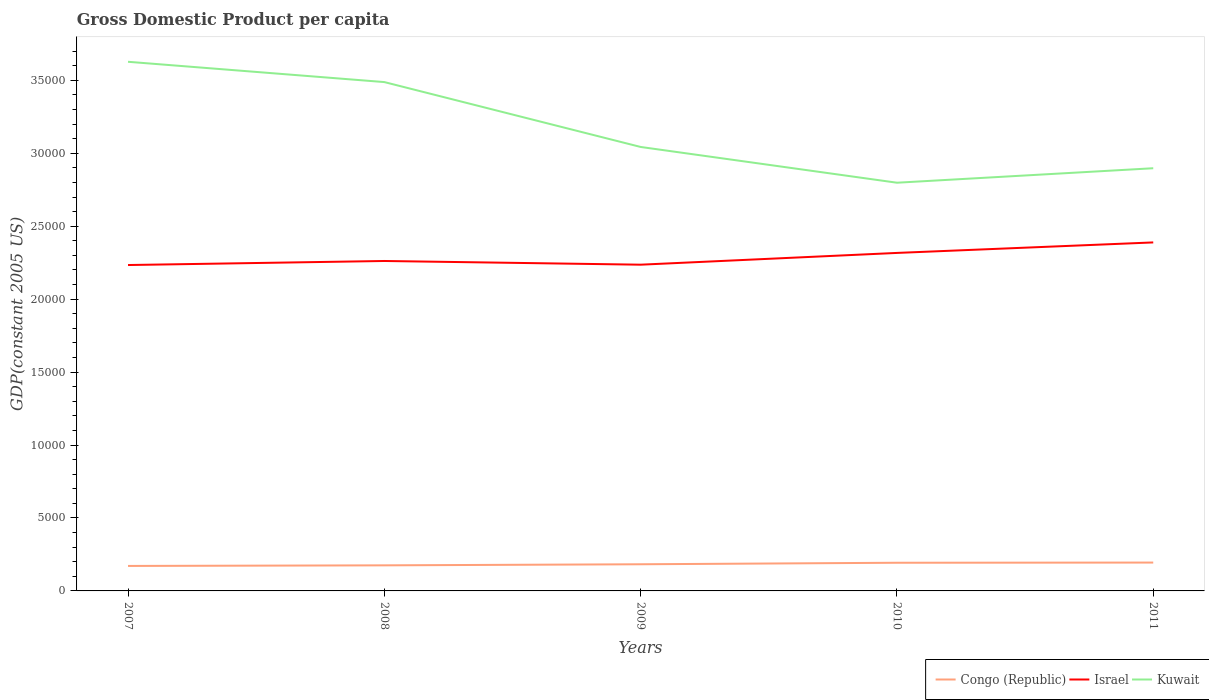Does the line corresponding to Congo (Republic) intersect with the line corresponding to Israel?
Offer a terse response. No. Across all years, what is the maximum GDP per capita in Kuwait?
Offer a terse response. 2.80e+04. In which year was the GDP per capita in Israel maximum?
Make the answer very short. 2007. What is the total GDP per capita in Congo (Republic) in the graph?
Make the answer very short. -231.26. What is the difference between the highest and the second highest GDP per capita in Israel?
Offer a very short reply. 1550.52. How many lines are there?
Offer a very short reply. 3. How many years are there in the graph?
Keep it short and to the point. 5. What is the difference between two consecutive major ticks on the Y-axis?
Make the answer very short. 5000. Does the graph contain grids?
Keep it short and to the point. No. Where does the legend appear in the graph?
Ensure brevity in your answer.  Bottom right. What is the title of the graph?
Offer a terse response. Gross Domestic Product per capita. Does "Zambia" appear as one of the legend labels in the graph?
Offer a terse response. No. What is the label or title of the X-axis?
Provide a succinct answer. Years. What is the label or title of the Y-axis?
Your answer should be very brief. GDP(constant 2005 US). What is the GDP(constant 2005 US) in Congo (Republic) in 2007?
Your answer should be very brief. 1712.82. What is the GDP(constant 2005 US) of Israel in 2007?
Keep it short and to the point. 2.23e+04. What is the GDP(constant 2005 US) of Kuwait in 2007?
Keep it short and to the point. 3.63e+04. What is the GDP(constant 2005 US) in Congo (Republic) in 2008?
Offer a terse response. 1753.02. What is the GDP(constant 2005 US) of Israel in 2008?
Your response must be concise. 2.26e+04. What is the GDP(constant 2005 US) of Kuwait in 2008?
Offer a very short reply. 3.49e+04. What is the GDP(constant 2005 US) of Congo (Republic) in 2009?
Offer a terse response. 1827.67. What is the GDP(constant 2005 US) in Israel in 2009?
Provide a succinct answer. 2.24e+04. What is the GDP(constant 2005 US) of Kuwait in 2009?
Offer a terse response. 3.04e+04. What is the GDP(constant 2005 US) in Congo (Republic) in 2010?
Your answer should be very brief. 1931.26. What is the GDP(constant 2005 US) in Israel in 2010?
Provide a succinct answer. 2.32e+04. What is the GDP(constant 2005 US) in Kuwait in 2010?
Offer a terse response. 2.80e+04. What is the GDP(constant 2005 US) of Congo (Republic) in 2011?
Your answer should be compact. 1944.08. What is the GDP(constant 2005 US) of Israel in 2011?
Provide a short and direct response. 2.39e+04. What is the GDP(constant 2005 US) of Kuwait in 2011?
Keep it short and to the point. 2.90e+04. Across all years, what is the maximum GDP(constant 2005 US) of Congo (Republic)?
Your answer should be very brief. 1944.08. Across all years, what is the maximum GDP(constant 2005 US) in Israel?
Provide a short and direct response. 2.39e+04. Across all years, what is the maximum GDP(constant 2005 US) of Kuwait?
Give a very brief answer. 3.63e+04. Across all years, what is the minimum GDP(constant 2005 US) in Congo (Republic)?
Provide a short and direct response. 1712.82. Across all years, what is the minimum GDP(constant 2005 US) in Israel?
Provide a succinct answer. 2.23e+04. Across all years, what is the minimum GDP(constant 2005 US) of Kuwait?
Offer a very short reply. 2.80e+04. What is the total GDP(constant 2005 US) of Congo (Republic) in the graph?
Give a very brief answer. 9168.85. What is the total GDP(constant 2005 US) of Israel in the graph?
Give a very brief answer. 1.14e+05. What is the total GDP(constant 2005 US) in Kuwait in the graph?
Offer a terse response. 1.59e+05. What is the difference between the GDP(constant 2005 US) in Congo (Republic) in 2007 and that in 2008?
Give a very brief answer. -40.19. What is the difference between the GDP(constant 2005 US) in Israel in 2007 and that in 2008?
Your answer should be compact. -278.04. What is the difference between the GDP(constant 2005 US) of Kuwait in 2007 and that in 2008?
Offer a terse response. 1391. What is the difference between the GDP(constant 2005 US) of Congo (Republic) in 2007 and that in 2009?
Give a very brief answer. -114.85. What is the difference between the GDP(constant 2005 US) of Israel in 2007 and that in 2009?
Offer a very short reply. -24.01. What is the difference between the GDP(constant 2005 US) in Kuwait in 2007 and that in 2009?
Ensure brevity in your answer.  5838.59. What is the difference between the GDP(constant 2005 US) in Congo (Republic) in 2007 and that in 2010?
Your response must be concise. -218.44. What is the difference between the GDP(constant 2005 US) of Israel in 2007 and that in 2010?
Your answer should be very brief. -830.64. What is the difference between the GDP(constant 2005 US) in Kuwait in 2007 and that in 2010?
Offer a terse response. 8289.89. What is the difference between the GDP(constant 2005 US) in Congo (Republic) in 2007 and that in 2011?
Offer a very short reply. -231.26. What is the difference between the GDP(constant 2005 US) in Israel in 2007 and that in 2011?
Your answer should be compact. -1550.52. What is the difference between the GDP(constant 2005 US) of Kuwait in 2007 and that in 2011?
Offer a very short reply. 7297.57. What is the difference between the GDP(constant 2005 US) in Congo (Republic) in 2008 and that in 2009?
Offer a very short reply. -74.65. What is the difference between the GDP(constant 2005 US) in Israel in 2008 and that in 2009?
Offer a very short reply. 254.03. What is the difference between the GDP(constant 2005 US) of Kuwait in 2008 and that in 2009?
Your response must be concise. 4447.59. What is the difference between the GDP(constant 2005 US) in Congo (Republic) in 2008 and that in 2010?
Your answer should be compact. -178.25. What is the difference between the GDP(constant 2005 US) of Israel in 2008 and that in 2010?
Ensure brevity in your answer.  -552.6. What is the difference between the GDP(constant 2005 US) of Kuwait in 2008 and that in 2010?
Offer a very short reply. 6898.89. What is the difference between the GDP(constant 2005 US) of Congo (Republic) in 2008 and that in 2011?
Make the answer very short. -191.07. What is the difference between the GDP(constant 2005 US) in Israel in 2008 and that in 2011?
Your answer should be very brief. -1272.48. What is the difference between the GDP(constant 2005 US) in Kuwait in 2008 and that in 2011?
Offer a terse response. 5906.57. What is the difference between the GDP(constant 2005 US) of Congo (Republic) in 2009 and that in 2010?
Ensure brevity in your answer.  -103.59. What is the difference between the GDP(constant 2005 US) of Israel in 2009 and that in 2010?
Give a very brief answer. -806.63. What is the difference between the GDP(constant 2005 US) of Kuwait in 2009 and that in 2010?
Ensure brevity in your answer.  2451.3. What is the difference between the GDP(constant 2005 US) in Congo (Republic) in 2009 and that in 2011?
Your answer should be compact. -116.41. What is the difference between the GDP(constant 2005 US) of Israel in 2009 and that in 2011?
Offer a terse response. -1526.51. What is the difference between the GDP(constant 2005 US) of Kuwait in 2009 and that in 2011?
Your answer should be compact. 1458.97. What is the difference between the GDP(constant 2005 US) in Congo (Republic) in 2010 and that in 2011?
Provide a short and direct response. -12.82. What is the difference between the GDP(constant 2005 US) of Israel in 2010 and that in 2011?
Keep it short and to the point. -719.88. What is the difference between the GDP(constant 2005 US) in Kuwait in 2010 and that in 2011?
Offer a terse response. -992.33. What is the difference between the GDP(constant 2005 US) in Congo (Republic) in 2007 and the GDP(constant 2005 US) in Israel in 2008?
Offer a terse response. -2.09e+04. What is the difference between the GDP(constant 2005 US) of Congo (Republic) in 2007 and the GDP(constant 2005 US) of Kuwait in 2008?
Offer a very short reply. -3.32e+04. What is the difference between the GDP(constant 2005 US) of Israel in 2007 and the GDP(constant 2005 US) of Kuwait in 2008?
Make the answer very short. -1.25e+04. What is the difference between the GDP(constant 2005 US) of Congo (Republic) in 2007 and the GDP(constant 2005 US) of Israel in 2009?
Your answer should be very brief. -2.07e+04. What is the difference between the GDP(constant 2005 US) in Congo (Republic) in 2007 and the GDP(constant 2005 US) in Kuwait in 2009?
Ensure brevity in your answer.  -2.87e+04. What is the difference between the GDP(constant 2005 US) of Israel in 2007 and the GDP(constant 2005 US) of Kuwait in 2009?
Your answer should be compact. -8094.24. What is the difference between the GDP(constant 2005 US) in Congo (Republic) in 2007 and the GDP(constant 2005 US) in Israel in 2010?
Offer a very short reply. -2.15e+04. What is the difference between the GDP(constant 2005 US) of Congo (Republic) in 2007 and the GDP(constant 2005 US) of Kuwait in 2010?
Offer a very short reply. -2.63e+04. What is the difference between the GDP(constant 2005 US) of Israel in 2007 and the GDP(constant 2005 US) of Kuwait in 2010?
Offer a very short reply. -5642.94. What is the difference between the GDP(constant 2005 US) of Congo (Republic) in 2007 and the GDP(constant 2005 US) of Israel in 2011?
Give a very brief answer. -2.22e+04. What is the difference between the GDP(constant 2005 US) of Congo (Republic) in 2007 and the GDP(constant 2005 US) of Kuwait in 2011?
Your answer should be compact. -2.73e+04. What is the difference between the GDP(constant 2005 US) of Israel in 2007 and the GDP(constant 2005 US) of Kuwait in 2011?
Your answer should be very brief. -6635.26. What is the difference between the GDP(constant 2005 US) in Congo (Republic) in 2008 and the GDP(constant 2005 US) in Israel in 2009?
Your answer should be compact. -2.06e+04. What is the difference between the GDP(constant 2005 US) in Congo (Republic) in 2008 and the GDP(constant 2005 US) in Kuwait in 2009?
Your answer should be compact. -2.87e+04. What is the difference between the GDP(constant 2005 US) of Israel in 2008 and the GDP(constant 2005 US) of Kuwait in 2009?
Your response must be concise. -7816.2. What is the difference between the GDP(constant 2005 US) in Congo (Republic) in 2008 and the GDP(constant 2005 US) in Israel in 2010?
Provide a short and direct response. -2.14e+04. What is the difference between the GDP(constant 2005 US) of Congo (Republic) in 2008 and the GDP(constant 2005 US) of Kuwait in 2010?
Provide a short and direct response. -2.62e+04. What is the difference between the GDP(constant 2005 US) in Israel in 2008 and the GDP(constant 2005 US) in Kuwait in 2010?
Ensure brevity in your answer.  -5364.89. What is the difference between the GDP(constant 2005 US) in Congo (Republic) in 2008 and the GDP(constant 2005 US) in Israel in 2011?
Offer a very short reply. -2.21e+04. What is the difference between the GDP(constant 2005 US) in Congo (Republic) in 2008 and the GDP(constant 2005 US) in Kuwait in 2011?
Your response must be concise. -2.72e+04. What is the difference between the GDP(constant 2005 US) of Israel in 2008 and the GDP(constant 2005 US) of Kuwait in 2011?
Ensure brevity in your answer.  -6357.22. What is the difference between the GDP(constant 2005 US) of Congo (Republic) in 2009 and the GDP(constant 2005 US) of Israel in 2010?
Your response must be concise. -2.13e+04. What is the difference between the GDP(constant 2005 US) in Congo (Republic) in 2009 and the GDP(constant 2005 US) in Kuwait in 2010?
Provide a short and direct response. -2.62e+04. What is the difference between the GDP(constant 2005 US) of Israel in 2009 and the GDP(constant 2005 US) of Kuwait in 2010?
Give a very brief answer. -5618.92. What is the difference between the GDP(constant 2005 US) in Congo (Republic) in 2009 and the GDP(constant 2005 US) in Israel in 2011?
Provide a short and direct response. -2.21e+04. What is the difference between the GDP(constant 2005 US) of Congo (Republic) in 2009 and the GDP(constant 2005 US) of Kuwait in 2011?
Make the answer very short. -2.71e+04. What is the difference between the GDP(constant 2005 US) in Israel in 2009 and the GDP(constant 2005 US) in Kuwait in 2011?
Offer a very short reply. -6611.25. What is the difference between the GDP(constant 2005 US) in Congo (Republic) in 2010 and the GDP(constant 2005 US) in Israel in 2011?
Ensure brevity in your answer.  -2.20e+04. What is the difference between the GDP(constant 2005 US) of Congo (Republic) in 2010 and the GDP(constant 2005 US) of Kuwait in 2011?
Make the answer very short. -2.70e+04. What is the difference between the GDP(constant 2005 US) in Israel in 2010 and the GDP(constant 2005 US) in Kuwait in 2011?
Make the answer very short. -5804.62. What is the average GDP(constant 2005 US) in Congo (Republic) per year?
Your answer should be very brief. 1833.77. What is the average GDP(constant 2005 US) in Israel per year?
Ensure brevity in your answer.  2.29e+04. What is the average GDP(constant 2005 US) of Kuwait per year?
Offer a terse response. 3.17e+04. In the year 2007, what is the difference between the GDP(constant 2005 US) in Congo (Republic) and GDP(constant 2005 US) in Israel?
Offer a very short reply. -2.06e+04. In the year 2007, what is the difference between the GDP(constant 2005 US) in Congo (Republic) and GDP(constant 2005 US) in Kuwait?
Your answer should be compact. -3.46e+04. In the year 2007, what is the difference between the GDP(constant 2005 US) of Israel and GDP(constant 2005 US) of Kuwait?
Make the answer very short. -1.39e+04. In the year 2008, what is the difference between the GDP(constant 2005 US) of Congo (Republic) and GDP(constant 2005 US) of Israel?
Your answer should be very brief. -2.09e+04. In the year 2008, what is the difference between the GDP(constant 2005 US) in Congo (Republic) and GDP(constant 2005 US) in Kuwait?
Your response must be concise. -3.31e+04. In the year 2008, what is the difference between the GDP(constant 2005 US) in Israel and GDP(constant 2005 US) in Kuwait?
Give a very brief answer. -1.23e+04. In the year 2009, what is the difference between the GDP(constant 2005 US) in Congo (Republic) and GDP(constant 2005 US) in Israel?
Your answer should be very brief. -2.05e+04. In the year 2009, what is the difference between the GDP(constant 2005 US) in Congo (Republic) and GDP(constant 2005 US) in Kuwait?
Your answer should be compact. -2.86e+04. In the year 2009, what is the difference between the GDP(constant 2005 US) of Israel and GDP(constant 2005 US) of Kuwait?
Your answer should be compact. -8070.22. In the year 2010, what is the difference between the GDP(constant 2005 US) in Congo (Republic) and GDP(constant 2005 US) in Israel?
Give a very brief answer. -2.12e+04. In the year 2010, what is the difference between the GDP(constant 2005 US) in Congo (Republic) and GDP(constant 2005 US) in Kuwait?
Your answer should be very brief. -2.61e+04. In the year 2010, what is the difference between the GDP(constant 2005 US) in Israel and GDP(constant 2005 US) in Kuwait?
Give a very brief answer. -4812.29. In the year 2011, what is the difference between the GDP(constant 2005 US) of Congo (Republic) and GDP(constant 2005 US) of Israel?
Your response must be concise. -2.19e+04. In the year 2011, what is the difference between the GDP(constant 2005 US) of Congo (Republic) and GDP(constant 2005 US) of Kuwait?
Offer a terse response. -2.70e+04. In the year 2011, what is the difference between the GDP(constant 2005 US) in Israel and GDP(constant 2005 US) in Kuwait?
Offer a terse response. -5084.74. What is the ratio of the GDP(constant 2005 US) of Congo (Republic) in 2007 to that in 2008?
Offer a very short reply. 0.98. What is the ratio of the GDP(constant 2005 US) of Israel in 2007 to that in 2008?
Your answer should be compact. 0.99. What is the ratio of the GDP(constant 2005 US) in Kuwait in 2007 to that in 2008?
Your response must be concise. 1.04. What is the ratio of the GDP(constant 2005 US) of Congo (Republic) in 2007 to that in 2009?
Provide a succinct answer. 0.94. What is the ratio of the GDP(constant 2005 US) of Kuwait in 2007 to that in 2009?
Keep it short and to the point. 1.19. What is the ratio of the GDP(constant 2005 US) in Congo (Republic) in 2007 to that in 2010?
Offer a terse response. 0.89. What is the ratio of the GDP(constant 2005 US) in Israel in 2007 to that in 2010?
Your answer should be very brief. 0.96. What is the ratio of the GDP(constant 2005 US) of Kuwait in 2007 to that in 2010?
Offer a terse response. 1.3. What is the ratio of the GDP(constant 2005 US) of Congo (Republic) in 2007 to that in 2011?
Provide a succinct answer. 0.88. What is the ratio of the GDP(constant 2005 US) in Israel in 2007 to that in 2011?
Offer a very short reply. 0.94. What is the ratio of the GDP(constant 2005 US) of Kuwait in 2007 to that in 2011?
Give a very brief answer. 1.25. What is the ratio of the GDP(constant 2005 US) in Congo (Republic) in 2008 to that in 2009?
Provide a succinct answer. 0.96. What is the ratio of the GDP(constant 2005 US) of Israel in 2008 to that in 2009?
Keep it short and to the point. 1.01. What is the ratio of the GDP(constant 2005 US) of Kuwait in 2008 to that in 2009?
Make the answer very short. 1.15. What is the ratio of the GDP(constant 2005 US) of Congo (Republic) in 2008 to that in 2010?
Ensure brevity in your answer.  0.91. What is the ratio of the GDP(constant 2005 US) in Israel in 2008 to that in 2010?
Provide a short and direct response. 0.98. What is the ratio of the GDP(constant 2005 US) of Kuwait in 2008 to that in 2010?
Ensure brevity in your answer.  1.25. What is the ratio of the GDP(constant 2005 US) in Congo (Republic) in 2008 to that in 2011?
Offer a very short reply. 0.9. What is the ratio of the GDP(constant 2005 US) of Israel in 2008 to that in 2011?
Your answer should be compact. 0.95. What is the ratio of the GDP(constant 2005 US) in Kuwait in 2008 to that in 2011?
Provide a succinct answer. 1.2. What is the ratio of the GDP(constant 2005 US) of Congo (Republic) in 2009 to that in 2010?
Offer a terse response. 0.95. What is the ratio of the GDP(constant 2005 US) of Israel in 2009 to that in 2010?
Offer a terse response. 0.97. What is the ratio of the GDP(constant 2005 US) of Kuwait in 2009 to that in 2010?
Offer a very short reply. 1.09. What is the ratio of the GDP(constant 2005 US) of Congo (Republic) in 2009 to that in 2011?
Ensure brevity in your answer.  0.94. What is the ratio of the GDP(constant 2005 US) of Israel in 2009 to that in 2011?
Your answer should be very brief. 0.94. What is the ratio of the GDP(constant 2005 US) of Kuwait in 2009 to that in 2011?
Give a very brief answer. 1.05. What is the ratio of the GDP(constant 2005 US) of Israel in 2010 to that in 2011?
Give a very brief answer. 0.97. What is the ratio of the GDP(constant 2005 US) of Kuwait in 2010 to that in 2011?
Offer a terse response. 0.97. What is the difference between the highest and the second highest GDP(constant 2005 US) of Congo (Republic)?
Your answer should be very brief. 12.82. What is the difference between the highest and the second highest GDP(constant 2005 US) in Israel?
Your answer should be very brief. 719.88. What is the difference between the highest and the second highest GDP(constant 2005 US) of Kuwait?
Offer a terse response. 1391. What is the difference between the highest and the lowest GDP(constant 2005 US) in Congo (Republic)?
Provide a succinct answer. 231.26. What is the difference between the highest and the lowest GDP(constant 2005 US) in Israel?
Provide a short and direct response. 1550.52. What is the difference between the highest and the lowest GDP(constant 2005 US) of Kuwait?
Ensure brevity in your answer.  8289.89. 